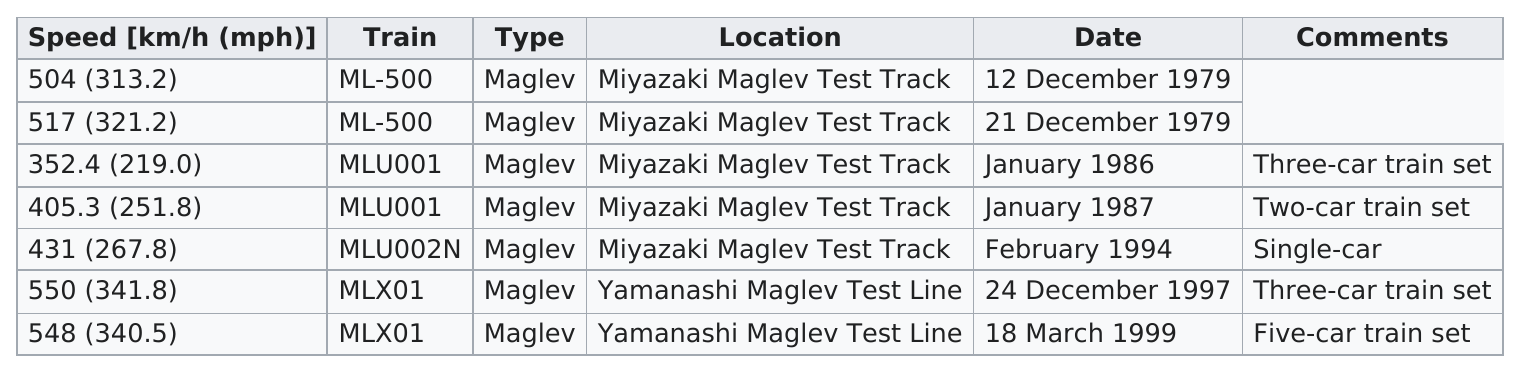Highlight a few significant elements in this photo. The ML-500 was the train that performed the best after the MLX01. Each train has a category that is shared with at least one other train. The last train listed is MLX01... The location for the first five consecutive tests was the Miyazaki Maglev Test Track. Additionally to the MLU001 train set, there were four other three-car train sets, which were referred to as the MLX01 train sets. 